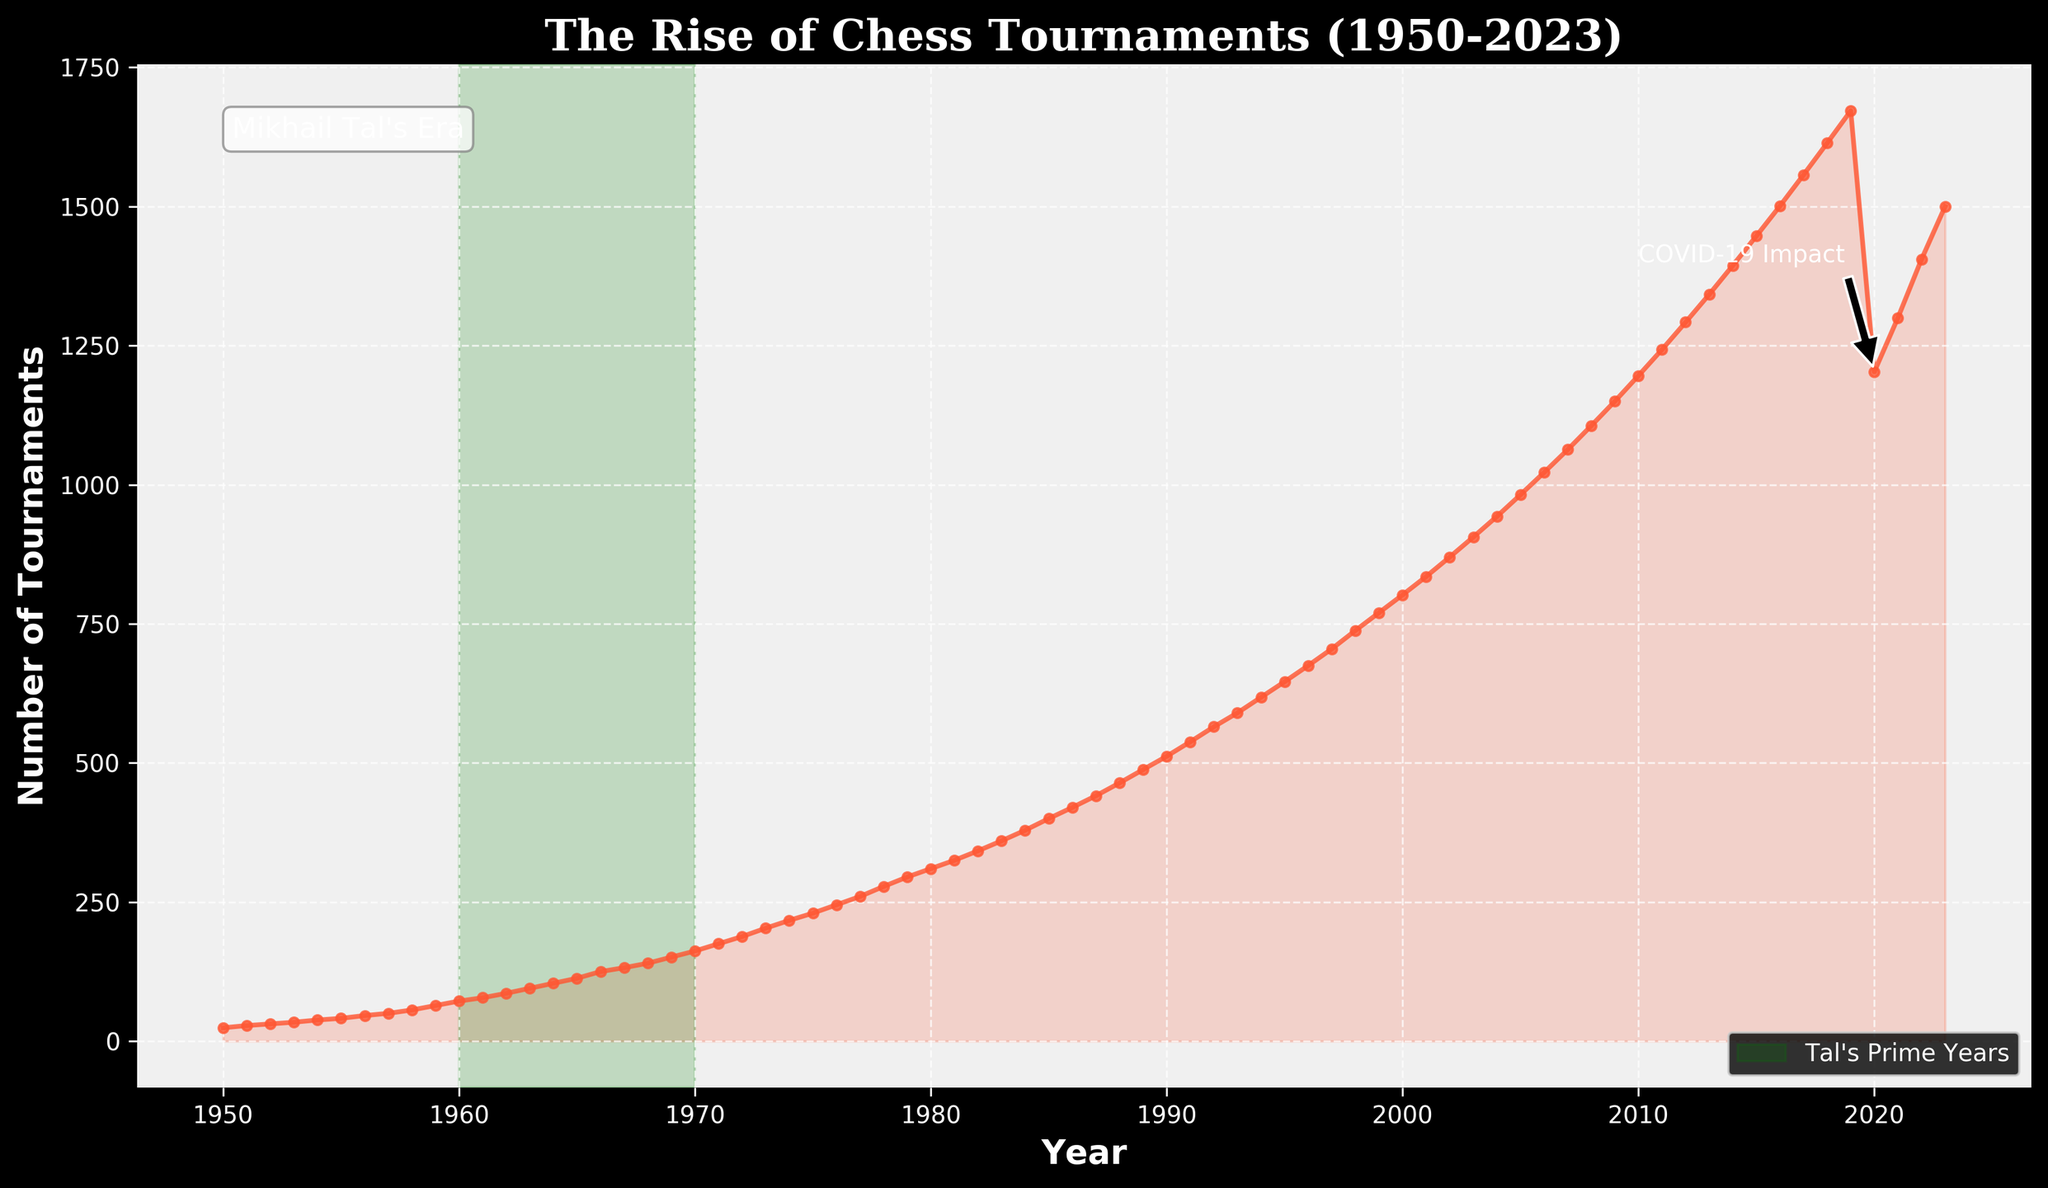What is the title of the plot? The plot's title is usually placed at the top and it clearly shows the main subject of the figure. The title here is "The Rise of Chess Tournaments (1950-2023)."
Answer: The Rise of Chess Tournaments (1950-2023) How many tournaments were held in 1950? Look at the corresponding point on the y-axis for the year 1950. The number of tournaments for 1950 is indicated as 24.
Answer: 24 What trend do you notice in the number of chess tournaments from 1950 to 2023? From the start of the plot in 1950 to the end in 2023, the general trend of the line increases consistently over time, indicating a rise in the number of chess tournaments held annually.
Answer: Increasing trend During which decade did the number of chess tournaments first surpass 100? Examine the plot to see when the y-values cross the 100 marker. This first happens during the 1960s. Specifically, in 1964, the number of tournaments is indicated as 104.
Answer: 1960s What is the significant annotation on the plot for the year 2020? There is a specific annotation with an arrow pointing to 2020 referencing the COVID-19 pandemic's impact. This is highlighted as "COVID-19 Impact."
Answer: COVID-19 Impact How is Mikhail Tal's prime years represented on the plot? Look for visual elements that highlight Tal's prime years. The plot uses a green shaded area spanning from 1960 to 1970 to mark "Tal's Prime Years."
Answer: Green shaded area from 1960 to 1970 In what year did the number of chess tournaments reach 500? Refer to the figure and find where the y-axis value first hits 500. This occurs around 1989.
Answer: 1989 Compare the number of tournaments held in 1960 and 2023. How much has it increased? Identify the number of tournaments for both years: 72 in 1960 and 1500 in 2023. Subtract the former from the latter to find the increase: 1500 - 72 = 1428.
Answer: Increased by 1428 Which year experienced a visible drop in the number of tournaments from the previous year? What might be the reason? Noticeable drop happens from 2019 to 2020 where the count falls from 1672 to 1203. The annotation "COVID-19 Impact" suggests that the pandemic caused this decline.
Answer: 2020, COVID-19 Impact What is the approximate average number of tournaments held per year during Mikhail Tal's prime years (1960-1970)? Note down the number of tournaments for each year between 1960 and 1970, sum them up, and divide by the number of years (11).
(72 + 78 + 86 + 95 + 104 + 113 + 125 + 132 + 140 + 151 + 162 = 1258; 1258 / 11 ≈ 114)
Answer: Around 114 